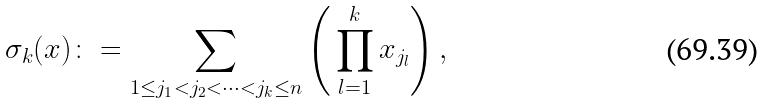Convert formula to latex. <formula><loc_0><loc_0><loc_500><loc_500>\sigma _ { k } ( x ) \colon = \sum _ { 1 \leq j _ { 1 } < j _ { 2 } < \dots < j _ { k } \leq n } \left ( \, \prod _ { l = 1 } ^ { k } x _ { j _ { l } } \right ) ,</formula> 